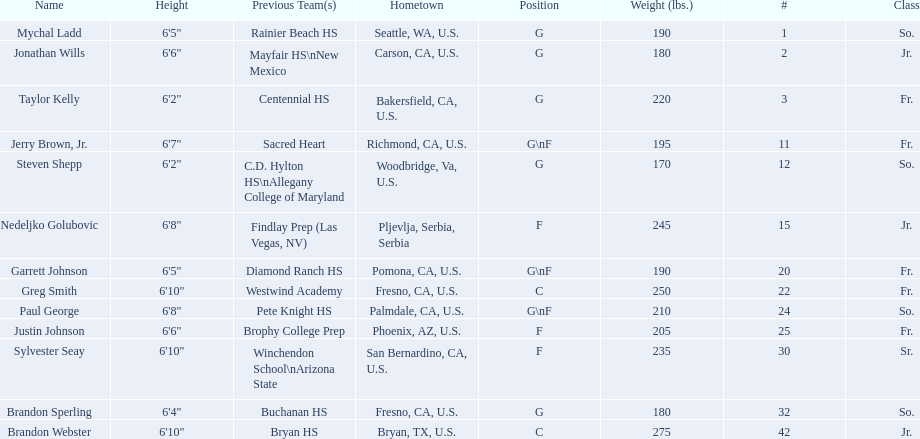Who are all the players in the 2009-10 fresno state bulldogs men's basketball team? Mychal Ladd, Jonathan Wills, Taylor Kelly, Jerry Brown, Jr., Steven Shepp, Nedeljko Golubovic, Garrett Johnson, Greg Smith, Paul George, Justin Johnson, Sylvester Seay, Brandon Sperling, Brandon Webster. Of these players, who are the ones who play forward? Jerry Brown, Jr., Nedeljko Golubovic, Garrett Johnson, Paul George, Justin Johnson, Sylvester Seay. Of these players, which ones only play forward and no other position? Nedeljko Golubovic, Justin Johnson, Sylvester Seay. Of these players, who is the shortest? Justin Johnson. 